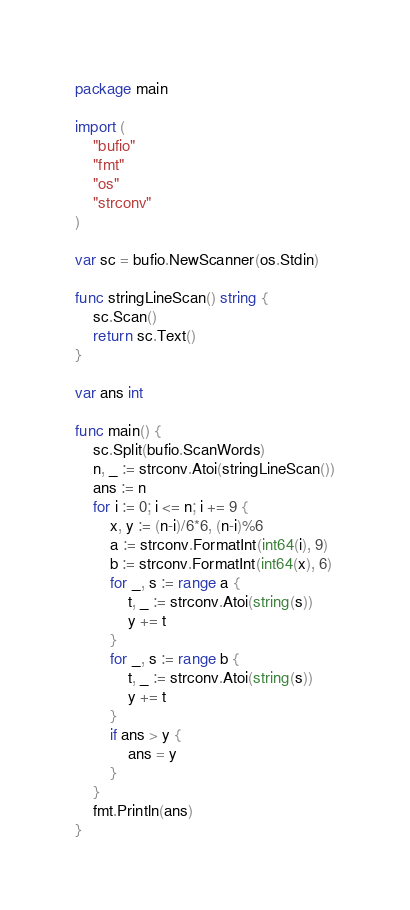<code> <loc_0><loc_0><loc_500><loc_500><_Go_>package main

import (
	"bufio"
	"fmt"
	"os"
	"strconv"
)

var sc = bufio.NewScanner(os.Stdin)

func stringLineScan() string {
	sc.Scan()
	return sc.Text()
}

var ans int

func main() {
	sc.Split(bufio.ScanWords)
	n, _ := strconv.Atoi(stringLineScan())
	ans := n
	for i := 0; i <= n; i += 9 {
		x, y := (n-i)/6*6, (n-i)%6
		a := strconv.FormatInt(int64(i), 9)
		b := strconv.FormatInt(int64(x), 6)
		for _, s := range a {
			t, _ := strconv.Atoi(string(s))
			y += t
		}
		for _, s := range b {
			t, _ := strconv.Atoi(string(s))
			y += t
		}
		if ans > y {
			ans = y
		}
	}
	fmt.Println(ans)
}
</code> 